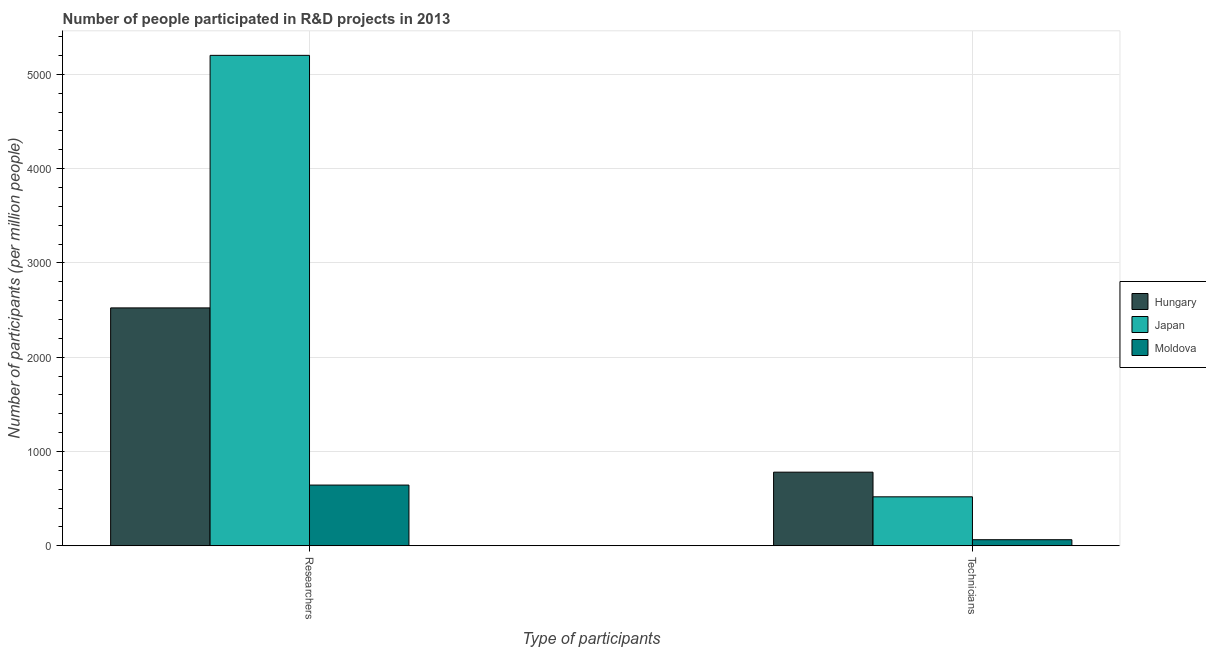How many different coloured bars are there?
Ensure brevity in your answer.  3. What is the label of the 2nd group of bars from the left?
Give a very brief answer. Technicians. What is the number of researchers in Japan?
Your answer should be very brief. 5201.32. Across all countries, what is the maximum number of researchers?
Your response must be concise. 5201.32. Across all countries, what is the minimum number of researchers?
Keep it short and to the point. 643.88. In which country was the number of researchers maximum?
Keep it short and to the point. Japan. In which country was the number of researchers minimum?
Provide a short and direct response. Moldova. What is the total number of technicians in the graph?
Provide a succinct answer. 1364.23. What is the difference between the number of researchers in Moldova and that in Japan?
Provide a succinct answer. -4557.43. What is the difference between the number of technicians in Hungary and the number of researchers in Moldova?
Give a very brief answer. 136.81. What is the average number of technicians per country?
Provide a short and direct response. 454.74. What is the difference between the number of technicians and number of researchers in Hungary?
Give a very brief answer. -1742.15. What is the ratio of the number of researchers in Japan to that in Hungary?
Provide a succinct answer. 2.06. In how many countries, is the number of researchers greater than the average number of researchers taken over all countries?
Your answer should be compact. 1. What does the 1st bar from the left in Technicians represents?
Provide a short and direct response. Hungary. What does the 2nd bar from the right in Researchers represents?
Offer a very short reply. Japan. How many bars are there?
Make the answer very short. 6. Are all the bars in the graph horizontal?
Your answer should be compact. No. How many countries are there in the graph?
Keep it short and to the point. 3. What is the difference between two consecutive major ticks on the Y-axis?
Keep it short and to the point. 1000. Are the values on the major ticks of Y-axis written in scientific E-notation?
Ensure brevity in your answer.  No. How many legend labels are there?
Offer a terse response. 3. How are the legend labels stacked?
Provide a short and direct response. Vertical. What is the title of the graph?
Your answer should be very brief. Number of people participated in R&D projects in 2013. What is the label or title of the X-axis?
Keep it short and to the point. Type of participants. What is the label or title of the Y-axis?
Your response must be concise. Number of participants (per million people). What is the Number of participants (per million people) of Hungary in Researchers?
Ensure brevity in your answer.  2522.85. What is the Number of participants (per million people) in Japan in Researchers?
Offer a terse response. 5201.32. What is the Number of participants (per million people) of Moldova in Researchers?
Offer a terse response. 643.88. What is the Number of participants (per million people) in Hungary in Technicians?
Your response must be concise. 780.69. What is the Number of participants (per million people) of Japan in Technicians?
Offer a terse response. 519.22. What is the Number of participants (per million people) in Moldova in Technicians?
Provide a short and direct response. 64.31. Across all Type of participants, what is the maximum Number of participants (per million people) in Hungary?
Give a very brief answer. 2522.85. Across all Type of participants, what is the maximum Number of participants (per million people) of Japan?
Your answer should be compact. 5201.32. Across all Type of participants, what is the maximum Number of participants (per million people) of Moldova?
Keep it short and to the point. 643.88. Across all Type of participants, what is the minimum Number of participants (per million people) in Hungary?
Give a very brief answer. 780.69. Across all Type of participants, what is the minimum Number of participants (per million people) in Japan?
Provide a succinct answer. 519.22. Across all Type of participants, what is the minimum Number of participants (per million people) of Moldova?
Give a very brief answer. 64.31. What is the total Number of participants (per million people) of Hungary in the graph?
Offer a very short reply. 3303.54. What is the total Number of participants (per million people) of Japan in the graph?
Your answer should be very brief. 5720.54. What is the total Number of participants (per million people) in Moldova in the graph?
Your answer should be compact. 708.2. What is the difference between the Number of participants (per million people) of Hungary in Researchers and that in Technicians?
Offer a terse response. 1742.15. What is the difference between the Number of participants (per million people) of Japan in Researchers and that in Technicians?
Your answer should be very brief. 4682.1. What is the difference between the Number of participants (per million people) of Moldova in Researchers and that in Technicians?
Keep it short and to the point. 579.57. What is the difference between the Number of participants (per million people) in Hungary in Researchers and the Number of participants (per million people) in Japan in Technicians?
Your response must be concise. 2003.63. What is the difference between the Number of participants (per million people) of Hungary in Researchers and the Number of participants (per million people) of Moldova in Technicians?
Offer a terse response. 2458.53. What is the difference between the Number of participants (per million people) in Japan in Researchers and the Number of participants (per million people) in Moldova in Technicians?
Keep it short and to the point. 5137. What is the average Number of participants (per million people) in Hungary per Type of participants?
Keep it short and to the point. 1651.77. What is the average Number of participants (per million people) of Japan per Type of participants?
Provide a short and direct response. 2860.27. What is the average Number of participants (per million people) of Moldova per Type of participants?
Your answer should be compact. 354.1. What is the difference between the Number of participants (per million people) of Hungary and Number of participants (per million people) of Japan in Researchers?
Provide a short and direct response. -2678.47. What is the difference between the Number of participants (per million people) of Hungary and Number of participants (per million people) of Moldova in Researchers?
Offer a terse response. 1878.96. What is the difference between the Number of participants (per million people) in Japan and Number of participants (per million people) in Moldova in Researchers?
Provide a short and direct response. 4557.43. What is the difference between the Number of participants (per million people) in Hungary and Number of participants (per million people) in Japan in Technicians?
Ensure brevity in your answer.  261.47. What is the difference between the Number of participants (per million people) of Hungary and Number of participants (per million people) of Moldova in Technicians?
Your answer should be compact. 716.38. What is the difference between the Number of participants (per million people) of Japan and Number of participants (per million people) of Moldova in Technicians?
Make the answer very short. 454.9. What is the ratio of the Number of participants (per million people) of Hungary in Researchers to that in Technicians?
Offer a terse response. 3.23. What is the ratio of the Number of participants (per million people) in Japan in Researchers to that in Technicians?
Offer a very short reply. 10.02. What is the ratio of the Number of participants (per million people) of Moldova in Researchers to that in Technicians?
Provide a succinct answer. 10.01. What is the difference between the highest and the second highest Number of participants (per million people) of Hungary?
Your response must be concise. 1742.15. What is the difference between the highest and the second highest Number of participants (per million people) in Japan?
Offer a terse response. 4682.1. What is the difference between the highest and the second highest Number of participants (per million people) of Moldova?
Offer a terse response. 579.57. What is the difference between the highest and the lowest Number of participants (per million people) of Hungary?
Keep it short and to the point. 1742.15. What is the difference between the highest and the lowest Number of participants (per million people) in Japan?
Keep it short and to the point. 4682.1. What is the difference between the highest and the lowest Number of participants (per million people) in Moldova?
Offer a terse response. 579.57. 